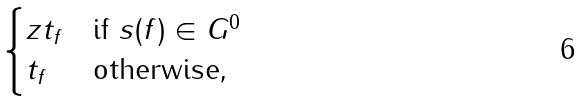<formula> <loc_0><loc_0><loc_500><loc_500>\begin{cases} z t _ { f } & \text {if $s(f) \in G^{0}$} \\ t _ { f } & \text {otherwise,} \end{cases}</formula> 